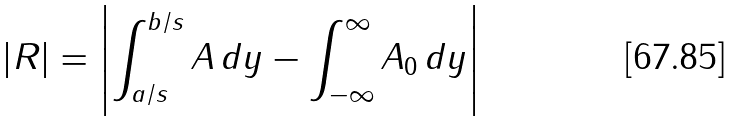Convert formula to latex. <formula><loc_0><loc_0><loc_500><loc_500>\left | R \right | = \left | \int _ { a / s } ^ { b / s } A \, d y - \int _ { - \infty } ^ { \infty } A _ { 0 } \, d y \right |</formula> 